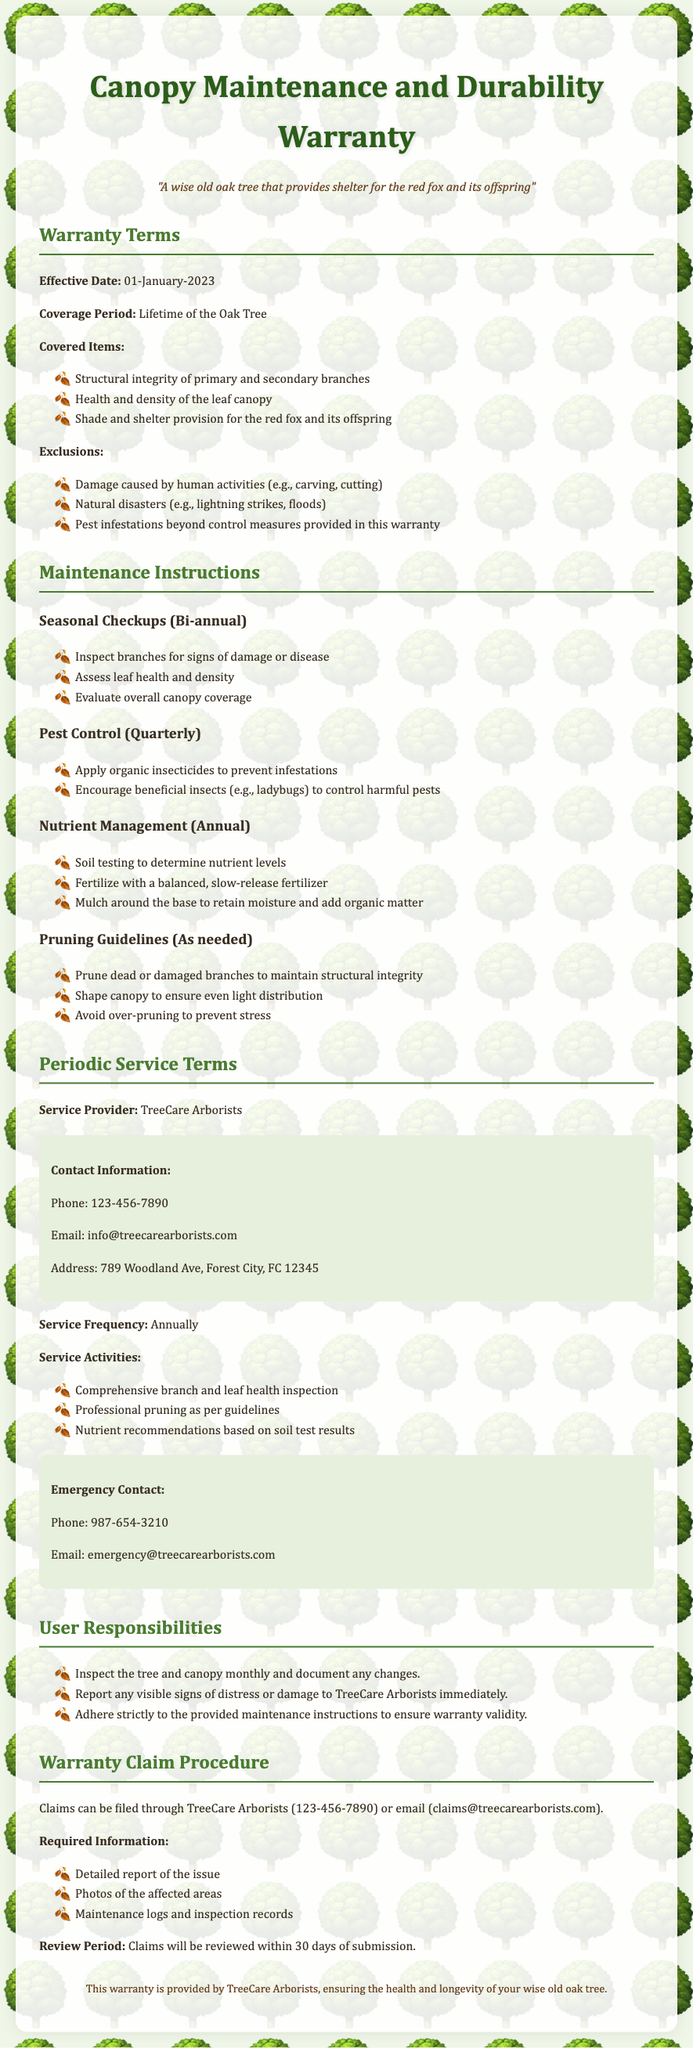What is the effective date of the warranty? The effective date is specified in the warranty terms section of the document as 01-January-2023.
Answer: 01-January-2023 What is the coverage period for the warranty? The coverage period is listed in the warranty terms as the lifetime of the oak tree.
Answer: Lifetime of the Oak Tree Who is the service provider mentioned in the document? The document specifies TreeCare Arborists as the service provider in the periodic service terms section.
Answer: TreeCare Arborists How often should seasonal checkups be performed? The maintenance instructions section states that seasonal checkups should be performed bi-annually.
Answer: Bi-annual What are the exclusions from the warranty? The warranty explicitly excludes damage caused by human activities, natural disasters, and pest infestations beyond control measures.
Answer: Damage caused by human activities, natural disasters, pest infestations beyond control measures What must a user do to ensure warranty validity? Users are instructed to adhere strictly to the provided maintenance instructions as part of their responsibilities.
Answer: Adhere strictly to the provided maintenance instructions What information is required to file a warranty claim? The warranty claim procedure outlines that a detailed report of the issue, photos of affected areas, and maintenance logs are required.
Answer: Detailed report of the issue, photos of affected areas, maintenance logs How frequently should pest control be applied according to the warranty? The maintenance instructions indicate that pest control should be performed quarterly.
Answer: Quarterly 